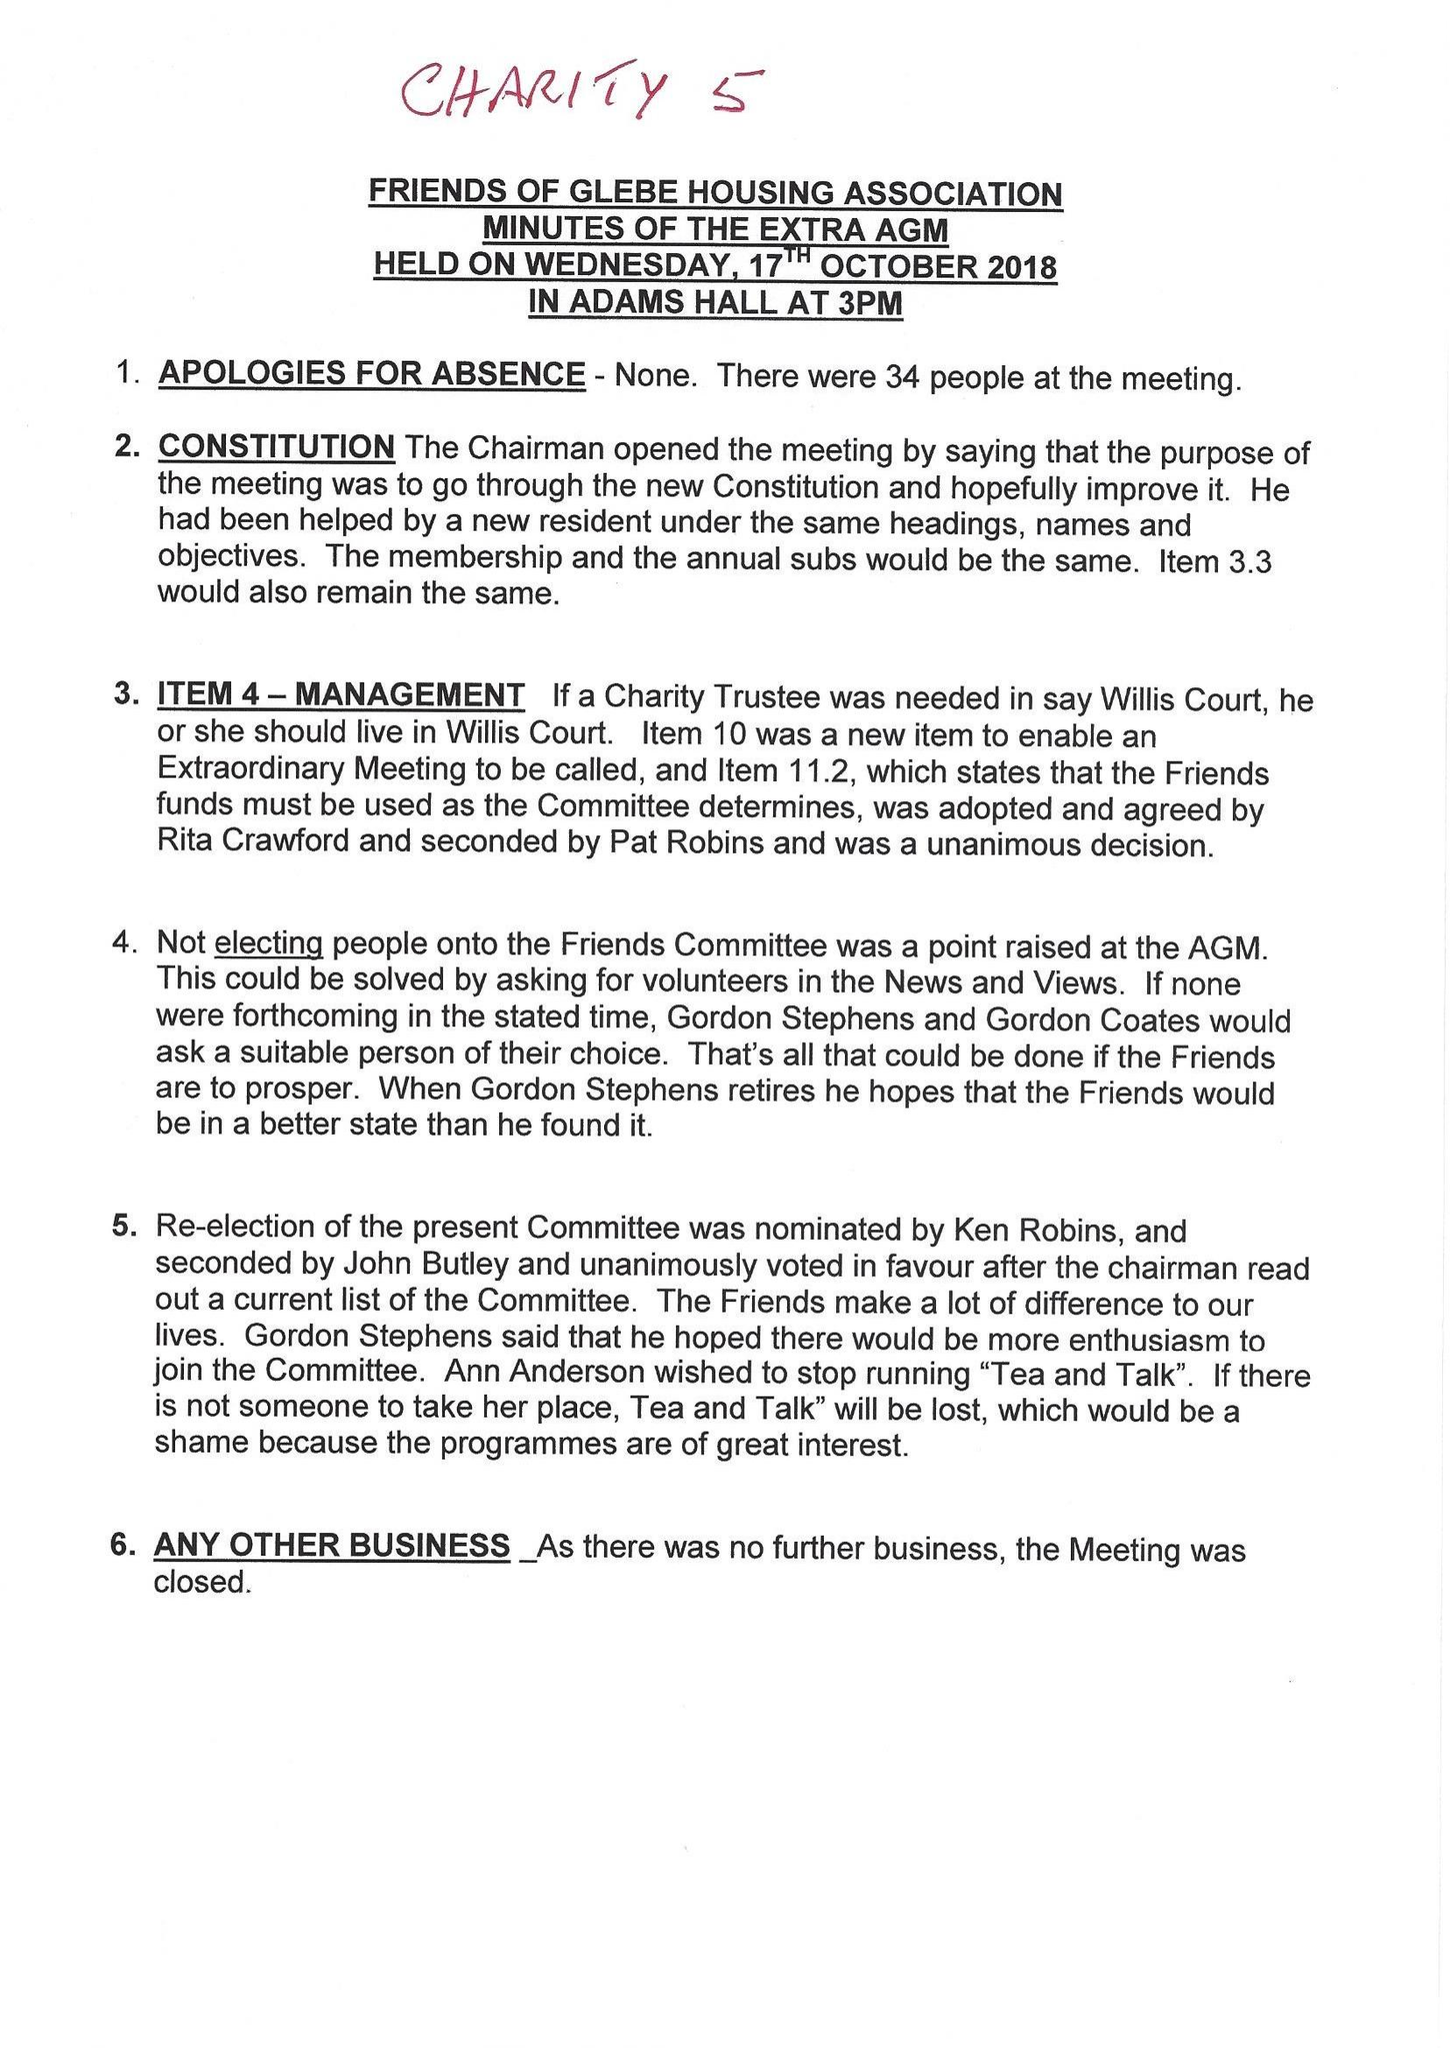What is the value for the address__post_town?
Answer the question using a single word or phrase. WEST WICKHAM 